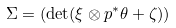<formula> <loc_0><loc_0><loc_500><loc_500>\Sigma = ( \det ( \xi \otimes p ^ { * } \theta + \zeta ) )</formula> 